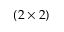Convert formula to latex. <formula><loc_0><loc_0><loc_500><loc_500>( 2 \times 2 )</formula> 